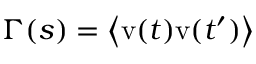Convert formula to latex. <formula><loc_0><loc_0><loc_500><loc_500>\Gamma ( s ) = \left < v ( t ) v ( t ^ { \prime } ) \right ></formula> 